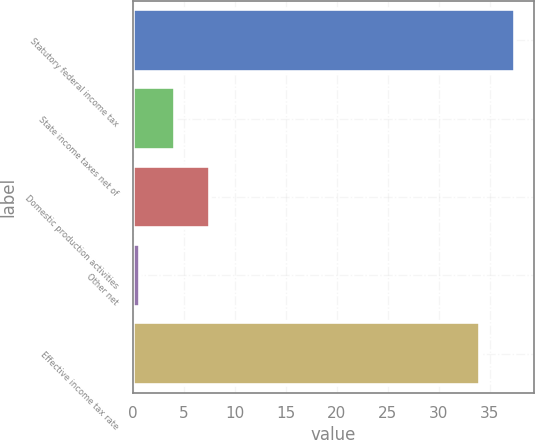Convert chart to OTSL. <chart><loc_0><loc_0><loc_500><loc_500><bar_chart><fcel>Statutory federal income tax<fcel>State income taxes net of<fcel>Domestic production activities<fcel>Other net<fcel>Effective income tax rate<nl><fcel>37.43<fcel>4.13<fcel>7.56<fcel>0.7<fcel>34<nl></chart> 